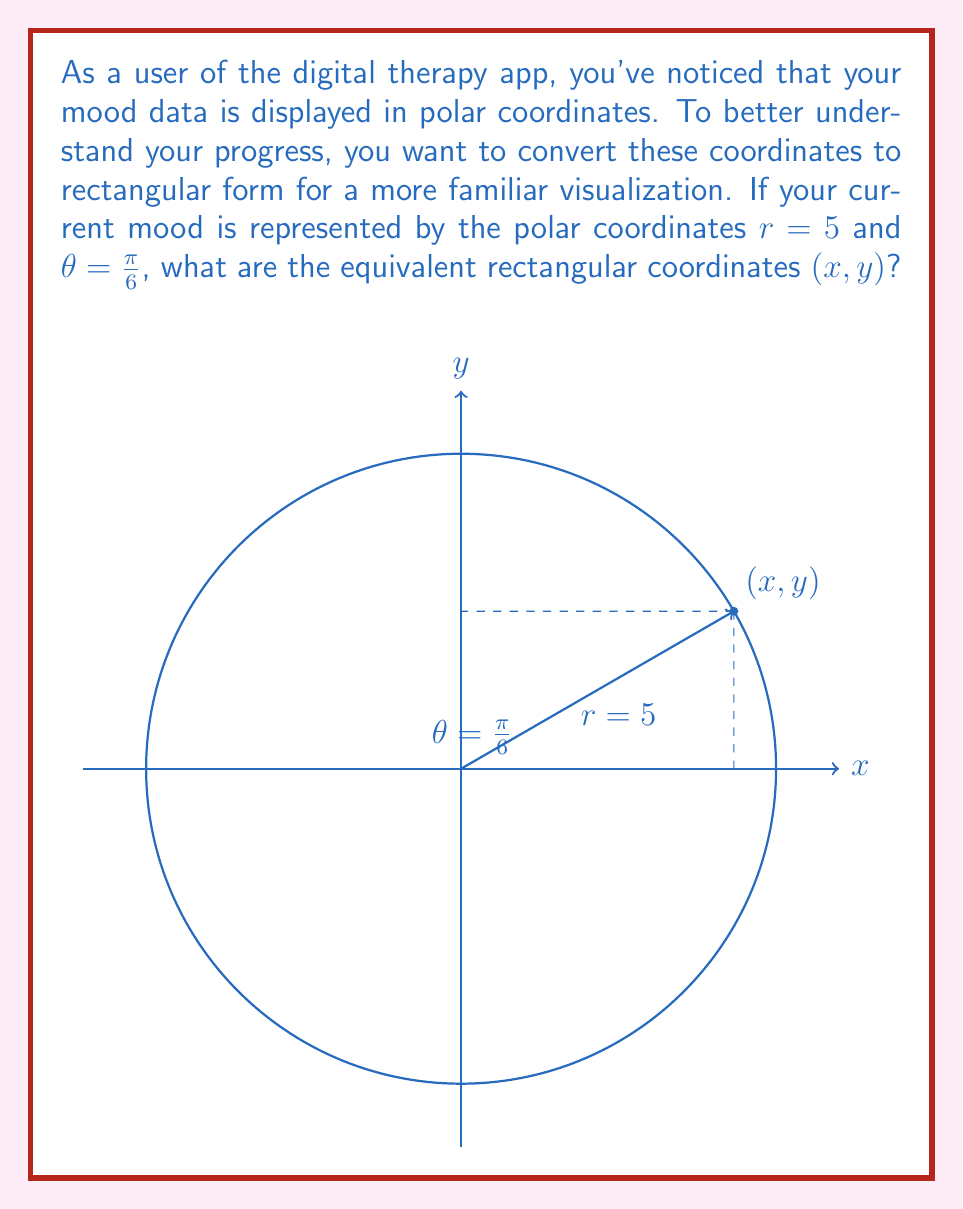Teach me how to tackle this problem. To convert polar coordinates $(r, \theta)$ to rectangular coordinates $(x, y)$, we use the following formulas:

1) $x = r \cos(\theta)$
2) $y = r \sin(\theta)$

Given:
- $r = 5$
- $\theta = \frac{\pi}{6}$

Let's calculate x:
$$x = r \cos(\theta) = 5 \cos(\frac{\pi}{6})$$
We know that $\cos(\frac{\pi}{6}) = \frac{\sqrt{3}}{2}$, so:
$$x = 5 \cdot \frac{\sqrt{3}}{2} = \frac{5\sqrt{3}}{2}$$

Now let's calculate y:
$$y = r \sin(\theta) = 5 \sin(\frac{\pi}{6})$$
We know that $\sin(\frac{\pi}{6}) = \frac{1}{2}$, so:
$$y = 5 \cdot \frac{1}{2} = \frac{5}{2}$$

Therefore, the rectangular coordinates are $(\frac{5\sqrt{3}}{2}, \frac{5}{2})$.
Answer: $(\frac{5\sqrt{3}}{2}, \frac{5}{2})$ 